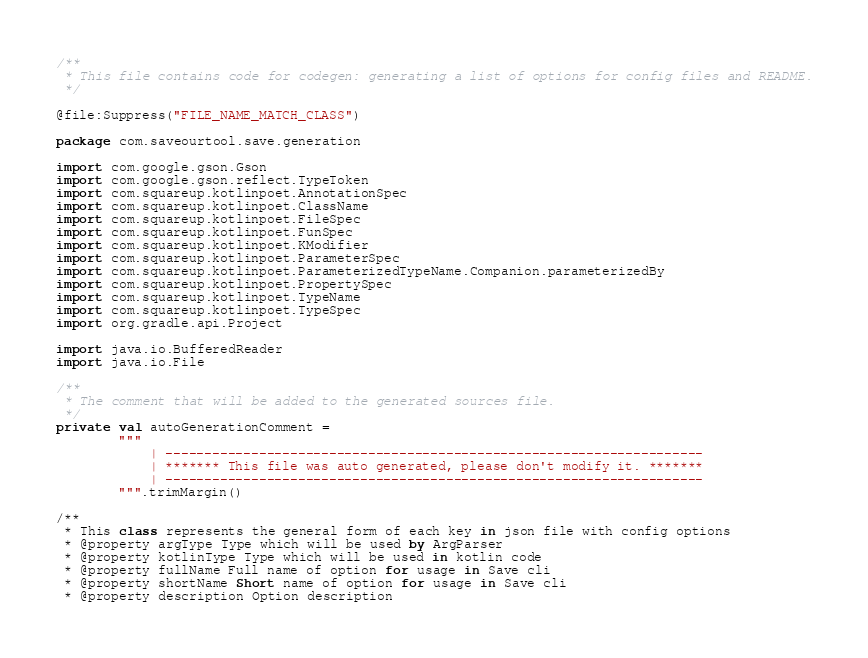Convert code to text. <code><loc_0><loc_0><loc_500><loc_500><_Kotlin_>/**
 * This file contains code for codegen: generating a list of options for config files and README.
 */

@file:Suppress("FILE_NAME_MATCH_CLASS")

package com.saveourtool.save.generation

import com.google.gson.Gson
import com.google.gson.reflect.TypeToken
import com.squareup.kotlinpoet.AnnotationSpec
import com.squareup.kotlinpoet.ClassName
import com.squareup.kotlinpoet.FileSpec
import com.squareup.kotlinpoet.FunSpec
import com.squareup.kotlinpoet.KModifier
import com.squareup.kotlinpoet.ParameterSpec
import com.squareup.kotlinpoet.ParameterizedTypeName.Companion.parameterizedBy
import com.squareup.kotlinpoet.PropertySpec
import com.squareup.kotlinpoet.TypeName
import com.squareup.kotlinpoet.TypeSpec
import org.gradle.api.Project

import java.io.BufferedReader
import java.io.File

/**
 * The comment that will be added to the generated sources file.
 */
private val autoGenerationComment =
        """
            | ---------------------------------------------------------------------
            | ******* This file was auto generated, please don't modify it. *******
            | ---------------------------------------------------------------------
        """.trimMargin()

/**
 * This class represents the general form of each key in json file with config options
 * @property argType Type which will be used by ArgParser
 * @property kotlinType Type which will be used in kotlin code
 * @property fullName Full name of option for usage in Save cli
 * @property shortName Short name of option for usage in Save cli
 * @property description Option description</code> 